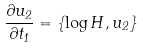<formula> <loc_0><loc_0><loc_500><loc_500>\frac { \partial u _ { 2 } } { \partial t _ { 1 } } = \{ \log H , u _ { 2 } \}</formula> 